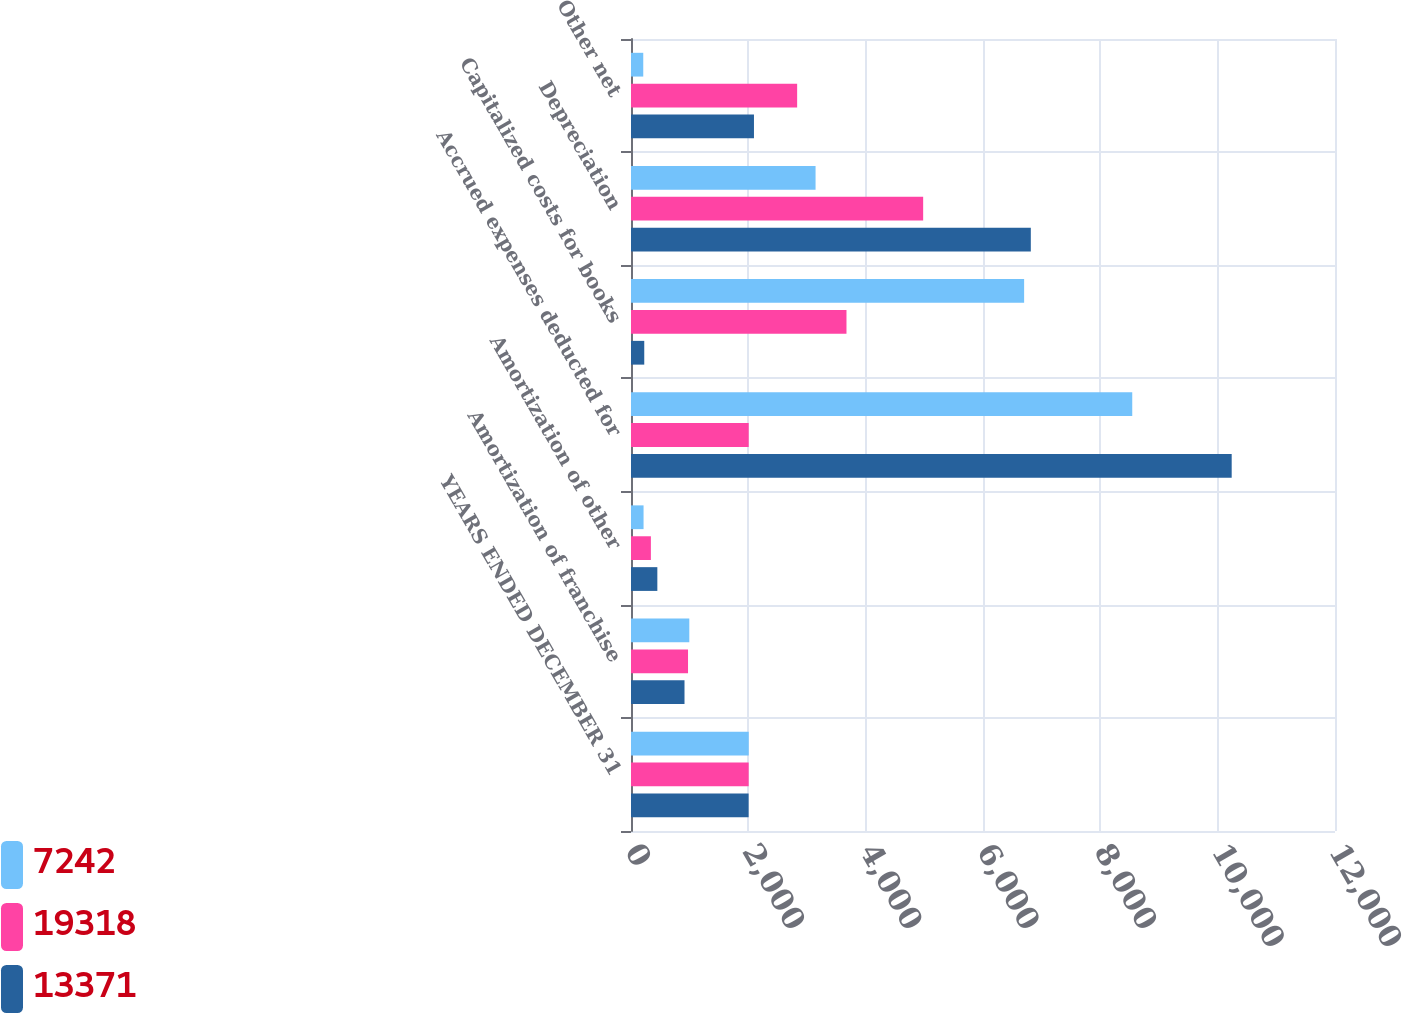Convert chart to OTSL. <chart><loc_0><loc_0><loc_500><loc_500><stacked_bar_chart><ecel><fcel>YEARS ENDED DECEMBER 31<fcel>Amortization of franchise<fcel>Amortization of other<fcel>Accrued expenses deducted for<fcel>Capitalized costs for books<fcel>Depreciation<fcel>Other net<nl><fcel>7242<fcel>2007<fcel>994<fcel>214<fcel>8544<fcel>6701<fcel>3146<fcel>209<nl><fcel>19318<fcel>2006<fcel>972<fcel>339<fcel>2006.5<fcel>3673<fcel>4980<fcel>2832<nl><fcel>13371<fcel>2005<fcel>912<fcel>449<fcel>10239<fcel>226<fcel>6815<fcel>2096<nl></chart> 